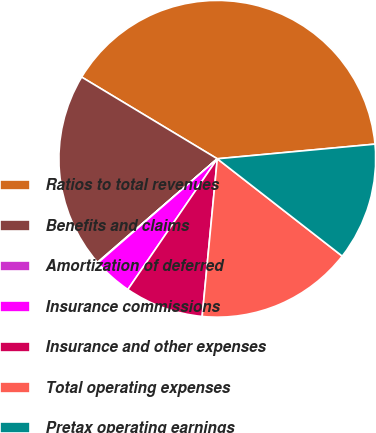Convert chart to OTSL. <chart><loc_0><loc_0><loc_500><loc_500><pie_chart><fcel>Ratios to total revenues<fcel>Benefits and claims<fcel>Amortization of deferred<fcel>Insurance commissions<fcel>Insurance and other expenses<fcel>Total operating expenses<fcel>Pretax operating earnings<nl><fcel>39.9%<fcel>19.98%<fcel>0.06%<fcel>4.04%<fcel>8.03%<fcel>15.99%<fcel>12.01%<nl></chart> 